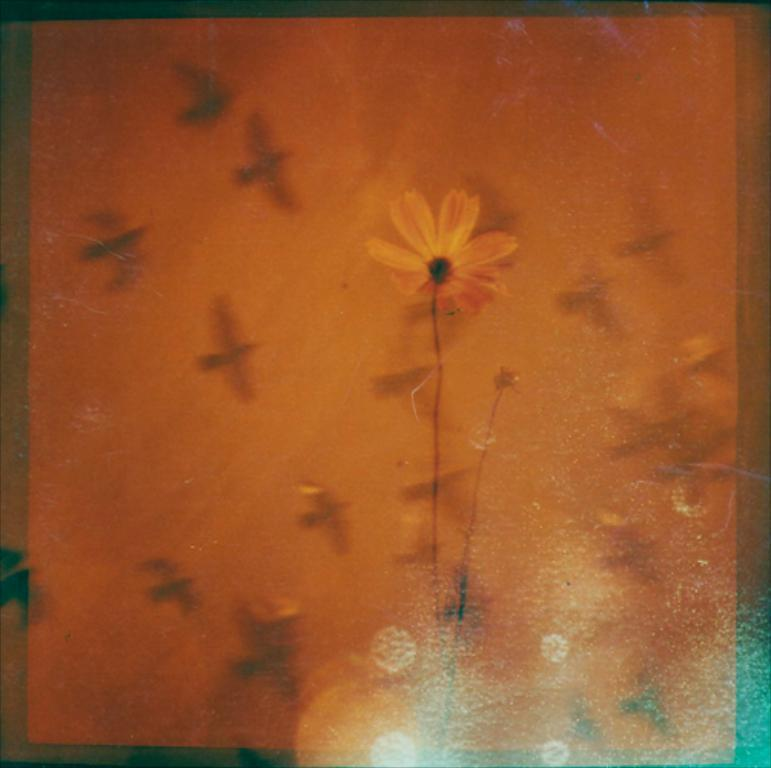What is the main subject of the image? There is a flower in the image. What can be seen connected to the flower? There are stems in the image. What else is happening in the image besides the flower and stems? Birds are flying in the air in the image. How many jellyfish are swimming in the water in the image? There is no water or jellyfish present in the image; it features a flower, stems, and birds flying in the air. 